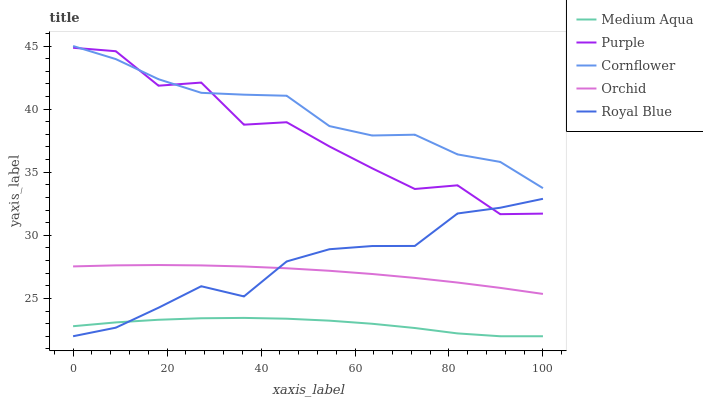Does Medium Aqua have the minimum area under the curve?
Answer yes or no. Yes. Does Cornflower have the maximum area under the curve?
Answer yes or no. Yes. Does Cornflower have the minimum area under the curve?
Answer yes or no. No. Does Medium Aqua have the maximum area under the curve?
Answer yes or no. No. Is Orchid the smoothest?
Answer yes or no. Yes. Is Purple the roughest?
Answer yes or no. Yes. Is Cornflower the smoothest?
Answer yes or no. No. Is Cornflower the roughest?
Answer yes or no. No. Does Medium Aqua have the lowest value?
Answer yes or no. Yes. Does Cornflower have the lowest value?
Answer yes or no. No. Does Cornflower have the highest value?
Answer yes or no. Yes. Does Medium Aqua have the highest value?
Answer yes or no. No. Is Medium Aqua less than Orchid?
Answer yes or no. Yes. Is Cornflower greater than Royal Blue?
Answer yes or no. Yes. Does Medium Aqua intersect Royal Blue?
Answer yes or no. Yes. Is Medium Aqua less than Royal Blue?
Answer yes or no. No. Is Medium Aqua greater than Royal Blue?
Answer yes or no. No. Does Medium Aqua intersect Orchid?
Answer yes or no. No. 